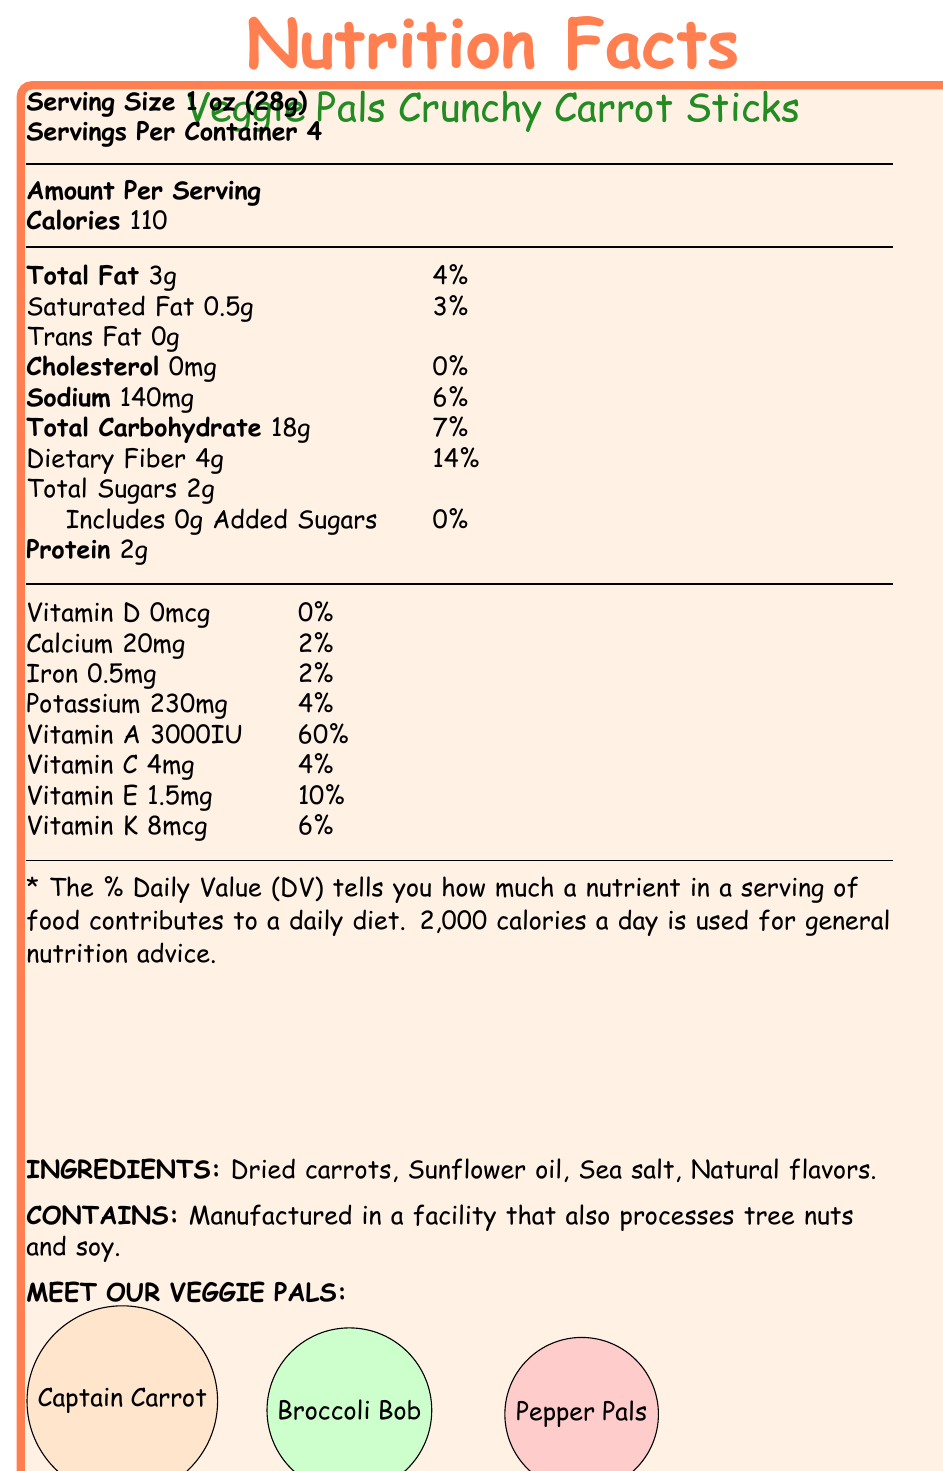what is the serving size? The serving size is clearly mentioned at the top of the Nutrition Facts section, as "Serving Size 1 oz (28g)".
Answer: 1 oz (28g) how many calories are in one serving? The document states, "Calories 110," which indicates the caloric content per serving.
Answer: 110 what percentage of the daily value of vitamin A does one serving contain? Under the vitamins section in the Nutrition Facts, it lists 3000IU of Vitamin A which equals 60% of the daily value.
Answer: 60% list the flavors used in Veggie Pals Crunchy Carrot Sticks The ingredients section lists "Natural flavors" as one of the components.
Answer: Natural flavors who are the cartoon characters on the packaging? The document describes the characters as Captain Carrot, Broccoli Bob, and Pepper Pals.
Answer: Captain Carrot, Broccoli Bob, Pepper Pals which nutrient has the highest percentage of the daily value in one serving? A. Dietary Fiber B. Vitamin A C. Vitamin E D. Sodium Vitamin A has 60% of the daily value, which is higher compared to other listed nutrients.
Answer: B what is the allergen information for this product? A. Contains peanuts B. Contains soy C. Contains gluten D. Contains dairy The document states that the product is manufactured in a facility that also processes tree nuts and soy.
Answer: B does this product contain any added sugars? The document mentions "Includes 0g Added Sugars," which indicates there are no added sugars.
Answer: No is this snack a healthier alternative to traditional snacks according to parental perception? The document mentions parental perception which states the product is seen as a "Healthier alternative to traditional snacks."
Answer: Yes summarize the whole document in a few sentences The document provides detailed nutritional information, ingredient list, allergen warnings, and highlights the target audience and marketing strategy for the Veggie Pals Crunchy Carrot Sticks.
Answer: The Veggie Pals Crunchy Carrot Sticks, featuring cartoon characters Captain Carrot, Broccoli Bob, and Pepper Pals, are a vegetable-based snack targeted at children aged 4-12. The snack boasts nutritional benefits such as being a good source of fiber and an excellent source of Vitamin A. The packaging uses bright orange colors to attract children and includes educational content about vegetables. Ingredients are natural, with no artificial additives, making it a preferred choice among health-conscious parents. what is the psychological appeal of the cartoon characters used in the marketing of the product? The document mentions that the characters are "Friendly and adventurous vegetable superheroes," which is part of their appeal.
Answer: Friendly and adventurous vegetable superheroes does the snack contain any cholesterol? The document clearly states "Cholesterol 0mg," meaning there’s no cholesterol in the snack.
Answer: No how many servings are in one container? The document states "Servings Per Container 4."
Answer: 4 why is the packaging designed in bright orange? The document indicates that the bright orange packaging is used for color psychology to stimulate appetite and energy.
Answer: To stimulate appetite and energy compare the dietary fiber percentage to the total carbohydrate percentage of daily values per serving The document lists dietary fiber at 14% and total carbohydrates at 7%, making dietary fiber twice as high in terms of daily value percentage.
Answer: Dietary fiber is 14% and total carbohydrate is 7%, so dietary fiber provides a higher percentage of daily value. how much protein is in one serving of this snack? The protein content listed in the document is 2g per serving.
Answer: 2g what is the branding or marketing claim regarding artificial ingredients? Under marketing claims, it is mentioned that the product has "No artificial colors or preservatives."
Answer: No artificial colors or preservatives what is the total sugar content in one serving? The document states "Total Sugars 2g."
Answer: 2g how much calcium is in one serving of the snack? The document lists calcium content as 20mg.
Answer: 20mg 